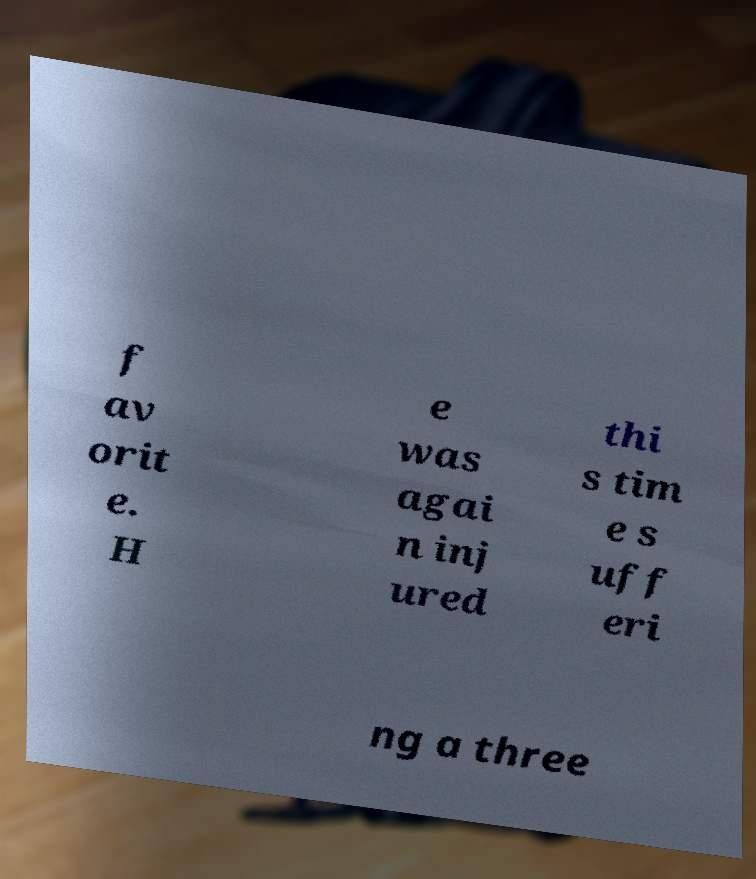Please identify and transcribe the text found in this image. f av orit e. H e was agai n inj ured thi s tim e s uff eri ng a three 